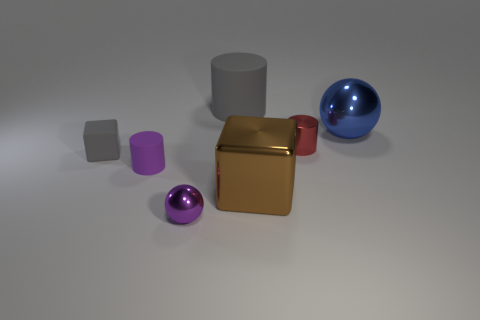Add 3 tiny red cylinders. How many objects exist? 10 Subtract all blocks. How many objects are left? 5 Subtract 1 gray blocks. How many objects are left? 6 Subtract all matte cubes. Subtract all purple rubber objects. How many objects are left? 5 Add 7 brown shiny cubes. How many brown shiny cubes are left? 8 Add 5 tiny rubber blocks. How many tiny rubber blocks exist? 6 